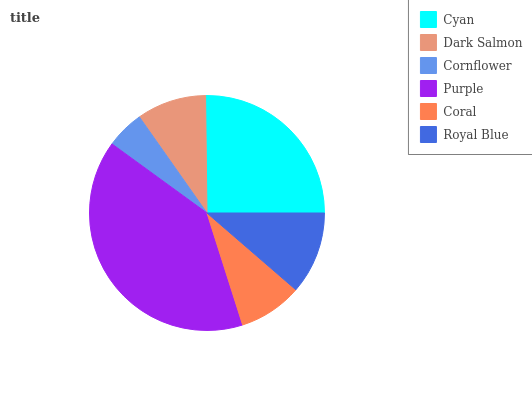Is Cornflower the minimum?
Answer yes or no. Yes. Is Purple the maximum?
Answer yes or no. Yes. Is Dark Salmon the minimum?
Answer yes or no. No. Is Dark Salmon the maximum?
Answer yes or no. No. Is Cyan greater than Dark Salmon?
Answer yes or no. Yes. Is Dark Salmon less than Cyan?
Answer yes or no. Yes. Is Dark Salmon greater than Cyan?
Answer yes or no. No. Is Cyan less than Dark Salmon?
Answer yes or no. No. Is Royal Blue the high median?
Answer yes or no. Yes. Is Dark Salmon the low median?
Answer yes or no. Yes. Is Dark Salmon the high median?
Answer yes or no. No. Is Cyan the low median?
Answer yes or no. No. 